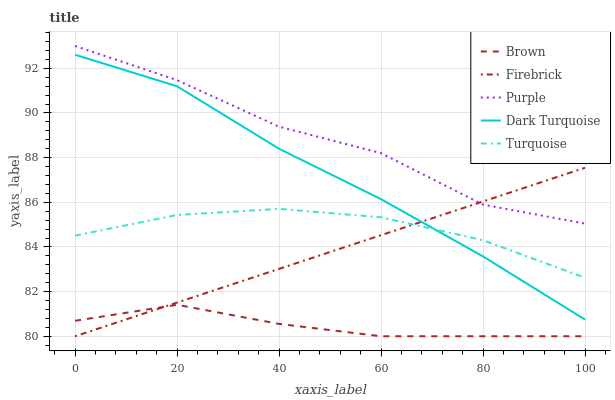Does Firebrick have the minimum area under the curve?
Answer yes or no. No. Does Firebrick have the maximum area under the curve?
Answer yes or no. No. Is Brown the smoothest?
Answer yes or no. No. Is Brown the roughest?
Answer yes or no. No. Does Turquoise have the lowest value?
Answer yes or no. No. Does Firebrick have the highest value?
Answer yes or no. No. Is Dark Turquoise less than Purple?
Answer yes or no. Yes. Is Dark Turquoise greater than Brown?
Answer yes or no. Yes. Does Dark Turquoise intersect Purple?
Answer yes or no. No. 